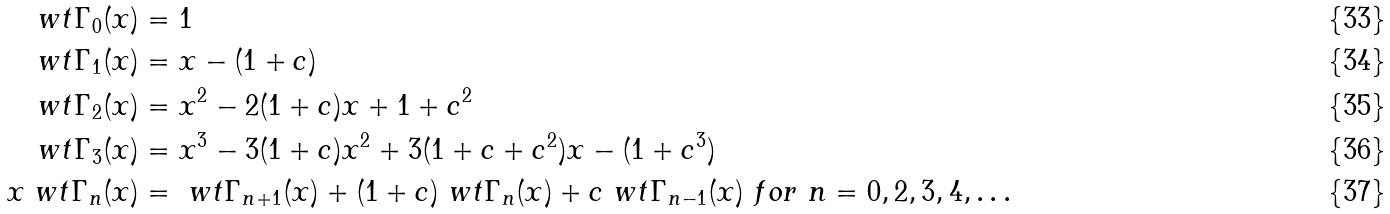<formula> <loc_0><loc_0><loc_500><loc_500>\ w t \Gamma _ { 0 } ( x ) & = 1 \\ \ w t \Gamma _ { 1 } ( x ) & = x - ( 1 + c ) \\ \ w t \Gamma _ { 2 } ( x ) & = x ^ { 2 } - 2 ( 1 + c ) x + 1 + c ^ { 2 } \\ \ w t \Gamma _ { 3 } ( x ) & = x ^ { 3 } - 3 ( 1 + c ) x ^ { 2 } + 3 ( 1 + c + c ^ { 2 } ) x - ( 1 + c ^ { 3 } ) \\ x \ w t \Gamma _ { n } ( x ) & = \ w t \Gamma _ { n + 1 } ( x ) + ( 1 + c ) \ w t \Gamma _ { n } ( x ) + c \ w t \Gamma _ { n - 1 } ( x ) \ f o r \ n = 0 , 2 , 3 , 4 , \dots</formula> 